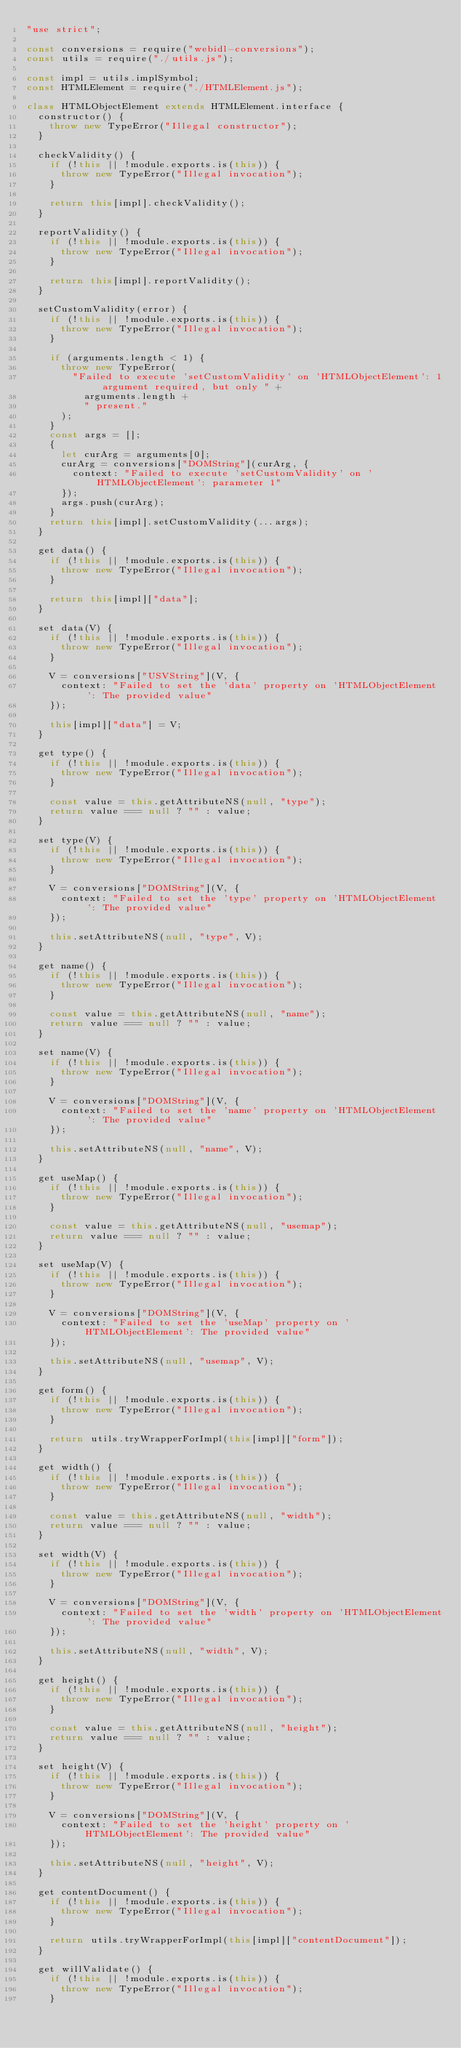Convert code to text. <code><loc_0><loc_0><loc_500><loc_500><_JavaScript_>"use strict";

const conversions = require("webidl-conversions");
const utils = require("./utils.js");

const impl = utils.implSymbol;
const HTMLElement = require("./HTMLElement.js");

class HTMLObjectElement extends HTMLElement.interface {
  constructor() {
    throw new TypeError("Illegal constructor");
  }

  checkValidity() {
    if (!this || !module.exports.is(this)) {
      throw new TypeError("Illegal invocation");
    }

    return this[impl].checkValidity();
  }

  reportValidity() {
    if (!this || !module.exports.is(this)) {
      throw new TypeError("Illegal invocation");
    }

    return this[impl].reportValidity();
  }

  setCustomValidity(error) {
    if (!this || !module.exports.is(this)) {
      throw new TypeError("Illegal invocation");
    }

    if (arguments.length < 1) {
      throw new TypeError(
        "Failed to execute 'setCustomValidity' on 'HTMLObjectElement': 1 argument required, but only " +
          arguments.length +
          " present."
      );
    }
    const args = [];
    {
      let curArg = arguments[0];
      curArg = conversions["DOMString"](curArg, {
        context: "Failed to execute 'setCustomValidity' on 'HTMLObjectElement': parameter 1"
      });
      args.push(curArg);
    }
    return this[impl].setCustomValidity(...args);
  }

  get data() {
    if (!this || !module.exports.is(this)) {
      throw new TypeError("Illegal invocation");
    }

    return this[impl]["data"];
  }

  set data(V) {
    if (!this || !module.exports.is(this)) {
      throw new TypeError("Illegal invocation");
    }

    V = conversions["USVString"](V, {
      context: "Failed to set the 'data' property on 'HTMLObjectElement': The provided value"
    });

    this[impl]["data"] = V;
  }

  get type() {
    if (!this || !module.exports.is(this)) {
      throw new TypeError("Illegal invocation");
    }

    const value = this.getAttributeNS(null, "type");
    return value === null ? "" : value;
  }

  set type(V) {
    if (!this || !module.exports.is(this)) {
      throw new TypeError("Illegal invocation");
    }

    V = conversions["DOMString"](V, {
      context: "Failed to set the 'type' property on 'HTMLObjectElement': The provided value"
    });

    this.setAttributeNS(null, "type", V);
  }

  get name() {
    if (!this || !module.exports.is(this)) {
      throw new TypeError("Illegal invocation");
    }

    const value = this.getAttributeNS(null, "name");
    return value === null ? "" : value;
  }

  set name(V) {
    if (!this || !module.exports.is(this)) {
      throw new TypeError("Illegal invocation");
    }

    V = conversions["DOMString"](V, {
      context: "Failed to set the 'name' property on 'HTMLObjectElement': The provided value"
    });

    this.setAttributeNS(null, "name", V);
  }

  get useMap() {
    if (!this || !module.exports.is(this)) {
      throw new TypeError("Illegal invocation");
    }

    const value = this.getAttributeNS(null, "usemap");
    return value === null ? "" : value;
  }

  set useMap(V) {
    if (!this || !module.exports.is(this)) {
      throw new TypeError("Illegal invocation");
    }

    V = conversions["DOMString"](V, {
      context: "Failed to set the 'useMap' property on 'HTMLObjectElement': The provided value"
    });

    this.setAttributeNS(null, "usemap", V);
  }

  get form() {
    if (!this || !module.exports.is(this)) {
      throw new TypeError("Illegal invocation");
    }

    return utils.tryWrapperForImpl(this[impl]["form"]);
  }

  get width() {
    if (!this || !module.exports.is(this)) {
      throw new TypeError("Illegal invocation");
    }

    const value = this.getAttributeNS(null, "width");
    return value === null ? "" : value;
  }

  set width(V) {
    if (!this || !module.exports.is(this)) {
      throw new TypeError("Illegal invocation");
    }

    V = conversions["DOMString"](V, {
      context: "Failed to set the 'width' property on 'HTMLObjectElement': The provided value"
    });

    this.setAttributeNS(null, "width", V);
  }

  get height() {
    if (!this || !module.exports.is(this)) {
      throw new TypeError("Illegal invocation");
    }

    const value = this.getAttributeNS(null, "height");
    return value === null ? "" : value;
  }

  set height(V) {
    if (!this || !module.exports.is(this)) {
      throw new TypeError("Illegal invocation");
    }

    V = conversions["DOMString"](V, {
      context: "Failed to set the 'height' property on 'HTMLObjectElement': The provided value"
    });

    this.setAttributeNS(null, "height", V);
  }

  get contentDocument() {
    if (!this || !module.exports.is(this)) {
      throw new TypeError("Illegal invocation");
    }

    return utils.tryWrapperForImpl(this[impl]["contentDocument"]);
  }

  get willValidate() {
    if (!this || !module.exports.is(this)) {
      throw new TypeError("Illegal invocation");
    }
</code> 